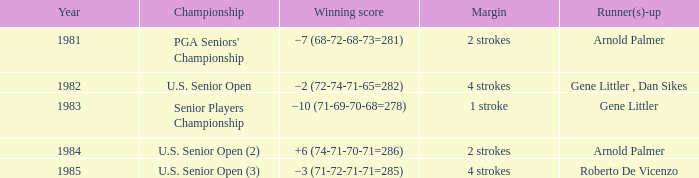What competition was in 1985? U.S. Senior Open (3). 